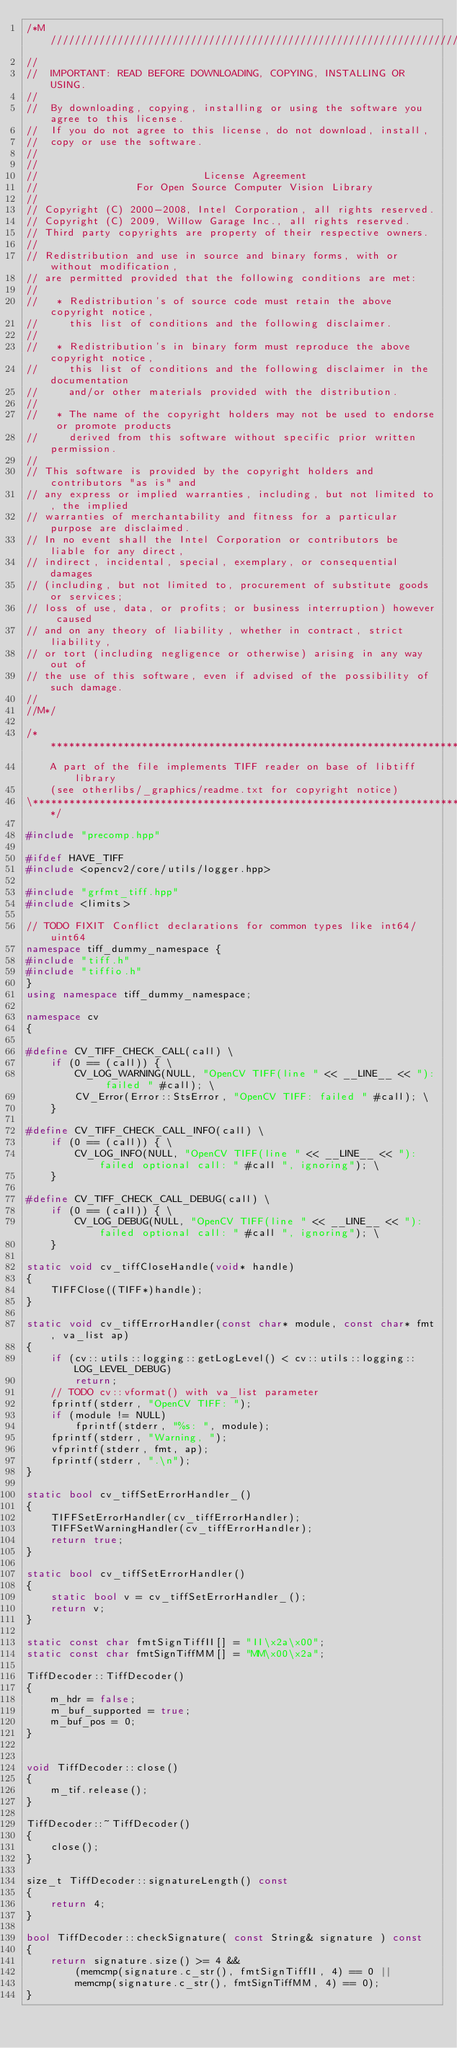<code> <loc_0><loc_0><loc_500><loc_500><_C++_>/*M///////////////////////////////////////////////////////////////////////////////////////
//
//  IMPORTANT: READ BEFORE DOWNLOADING, COPYING, INSTALLING OR USING.
//
//  By downloading, copying, installing or using the software you agree to this license.
//  If you do not agree to this license, do not download, install,
//  copy or use the software.
//
//
//                           License Agreement
//                For Open Source Computer Vision Library
//
// Copyright (C) 2000-2008, Intel Corporation, all rights reserved.
// Copyright (C) 2009, Willow Garage Inc., all rights reserved.
// Third party copyrights are property of their respective owners.
//
// Redistribution and use in source and binary forms, with or without modification,
// are permitted provided that the following conditions are met:
//
//   * Redistribution's of source code must retain the above copyright notice,
//     this list of conditions and the following disclaimer.
//
//   * Redistribution's in binary form must reproduce the above copyright notice,
//     this list of conditions and the following disclaimer in the documentation
//     and/or other materials provided with the distribution.
//
//   * The name of the copyright holders may not be used to endorse or promote products
//     derived from this software without specific prior written permission.
//
// This software is provided by the copyright holders and contributors "as is" and
// any express or implied warranties, including, but not limited to, the implied
// warranties of merchantability and fitness for a particular purpose are disclaimed.
// In no event shall the Intel Corporation or contributors be liable for any direct,
// indirect, incidental, special, exemplary, or consequential damages
// (including, but not limited to, procurement of substitute goods or services;
// loss of use, data, or profits; or business interruption) however caused
// and on any theory of liability, whether in contract, strict liability,
// or tort (including negligence or otherwise) arising in any way out of
// the use of this software, even if advised of the possibility of such damage.
//
//M*/

/****************************************************************************************\
    A part of the file implements TIFF reader on base of libtiff library
    (see otherlibs/_graphics/readme.txt for copyright notice)
\****************************************************************************************/

#include "precomp.hpp"

#ifdef HAVE_TIFF
#include <opencv2/core/utils/logger.hpp>

#include "grfmt_tiff.hpp"
#include <limits>

// TODO FIXIT Conflict declarations for common types like int64/uint64
namespace tiff_dummy_namespace {
#include "tiff.h"
#include "tiffio.h"
}
using namespace tiff_dummy_namespace;

namespace cv
{

#define CV_TIFF_CHECK_CALL(call) \
    if (0 == (call)) { \
        CV_LOG_WARNING(NULL, "OpenCV TIFF(line " << __LINE__ << "): failed " #call); \
        CV_Error(Error::StsError, "OpenCV TIFF: failed " #call); \
    }

#define CV_TIFF_CHECK_CALL_INFO(call) \
    if (0 == (call)) { \
        CV_LOG_INFO(NULL, "OpenCV TIFF(line " << __LINE__ << "): failed optional call: " #call ", ignoring"); \
    }

#define CV_TIFF_CHECK_CALL_DEBUG(call) \
    if (0 == (call)) { \
        CV_LOG_DEBUG(NULL, "OpenCV TIFF(line " << __LINE__ << "): failed optional call: " #call ", ignoring"); \
    }

static void cv_tiffCloseHandle(void* handle)
{
    TIFFClose((TIFF*)handle);
}

static void cv_tiffErrorHandler(const char* module, const char* fmt, va_list ap)
{
    if (cv::utils::logging::getLogLevel() < cv::utils::logging::LOG_LEVEL_DEBUG)
        return;
    // TODO cv::vformat() with va_list parameter
    fprintf(stderr, "OpenCV TIFF: ");
    if (module != NULL)
        fprintf(stderr, "%s: ", module);
    fprintf(stderr, "Warning, ");
    vfprintf(stderr, fmt, ap);
    fprintf(stderr, ".\n");
}

static bool cv_tiffSetErrorHandler_()
{
    TIFFSetErrorHandler(cv_tiffErrorHandler);
    TIFFSetWarningHandler(cv_tiffErrorHandler);
    return true;
}

static bool cv_tiffSetErrorHandler()
{
    static bool v = cv_tiffSetErrorHandler_();
    return v;
}

static const char fmtSignTiffII[] = "II\x2a\x00";
static const char fmtSignTiffMM[] = "MM\x00\x2a";

TiffDecoder::TiffDecoder()
{
    m_hdr = false;
    m_buf_supported = true;
    m_buf_pos = 0;
}


void TiffDecoder::close()
{
    m_tif.release();
}

TiffDecoder::~TiffDecoder()
{
    close();
}

size_t TiffDecoder::signatureLength() const
{
    return 4;
}

bool TiffDecoder::checkSignature( const String& signature ) const
{
    return signature.size() >= 4 &&
        (memcmp(signature.c_str(), fmtSignTiffII, 4) == 0 ||
        memcmp(signature.c_str(), fmtSignTiffMM, 4) == 0);
}
</code> 